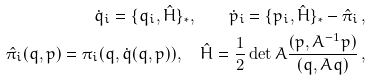<formula> <loc_0><loc_0><loc_500><loc_500>\dot { q } _ { i } = \{ q _ { i } , \hat { H } \} _ { * } , \quad \dot { p } _ { i } = \{ p _ { i } , \hat { H } \} _ { * } - \hat { \pi } _ { i } \, , \\ \hat { \pi } _ { i } ( q , p ) = \pi _ { i } ( q , \dot { q } ( q , p ) ) , \quad \hat { H } = \frac { 1 } { 2 } \det A \frac { ( p , A ^ { - 1 } p ) } { ( q , A q ) } \, ,</formula> 